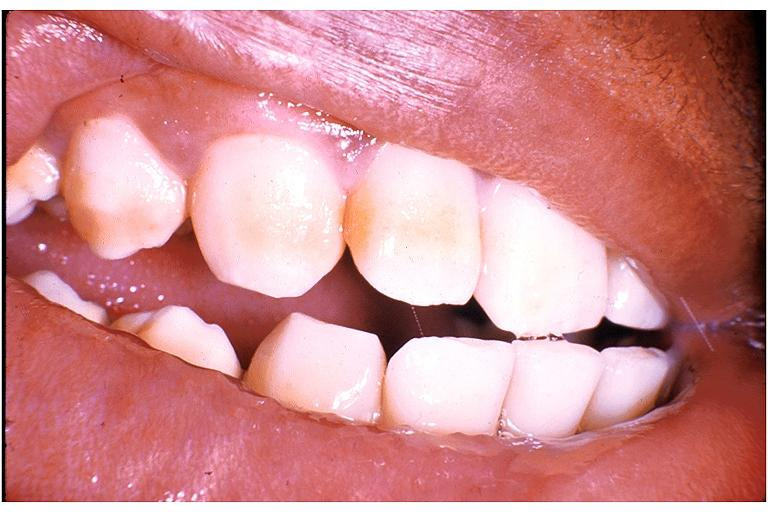s adenocarcinoma present?
Answer the question using a single word or phrase. No 